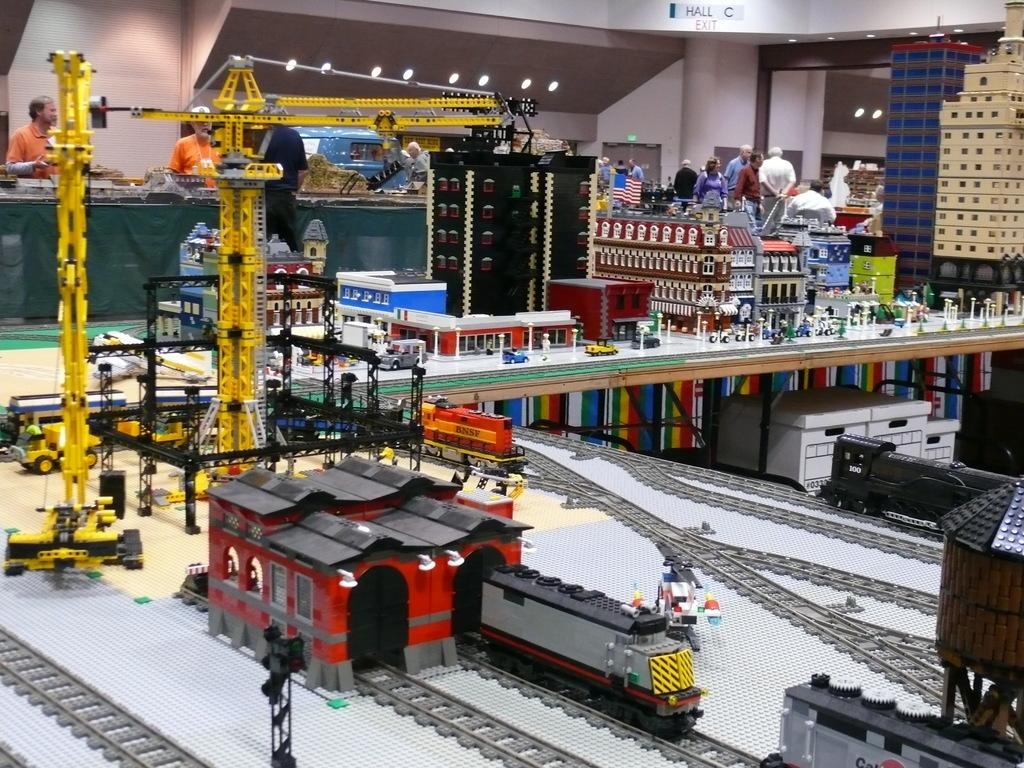What type of establishment is depicted in the image? The image appears to be a toy shop. Can you describe the people in the image? There are multiple persons standing in the middle of the image. What type of oatmeal is being prepared in the toy shop? There is no oatmeal present in the image, as it is a toy shop and not a kitchen or food establishment. 